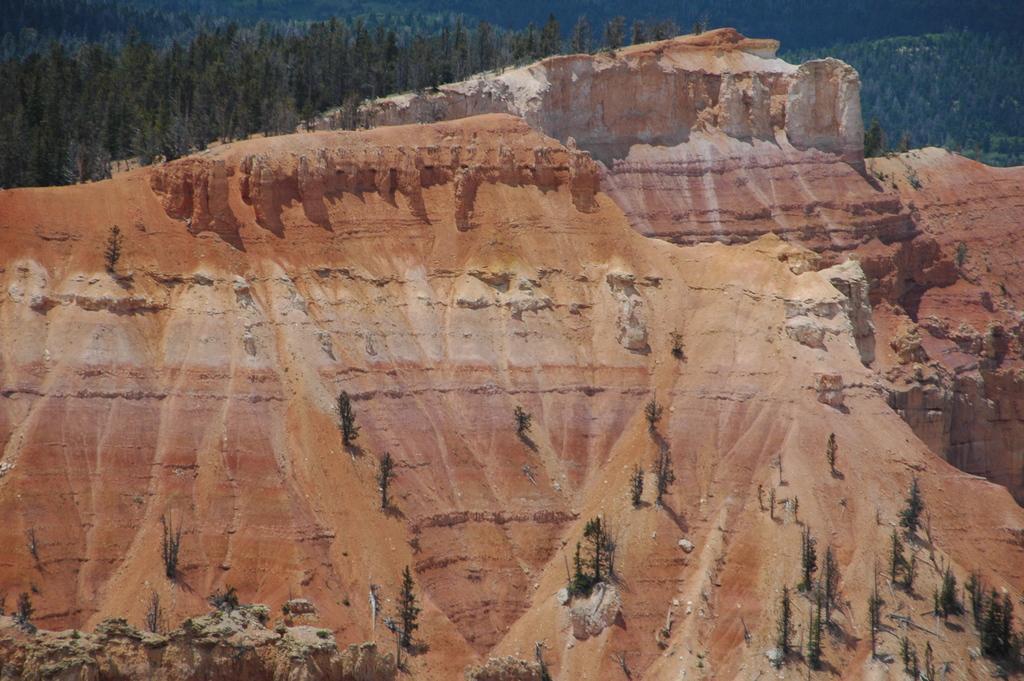Please provide a concise description of this image. This image consists of mountains. And there are plants. At the top, we can see the sky. On the left, there are trees. 